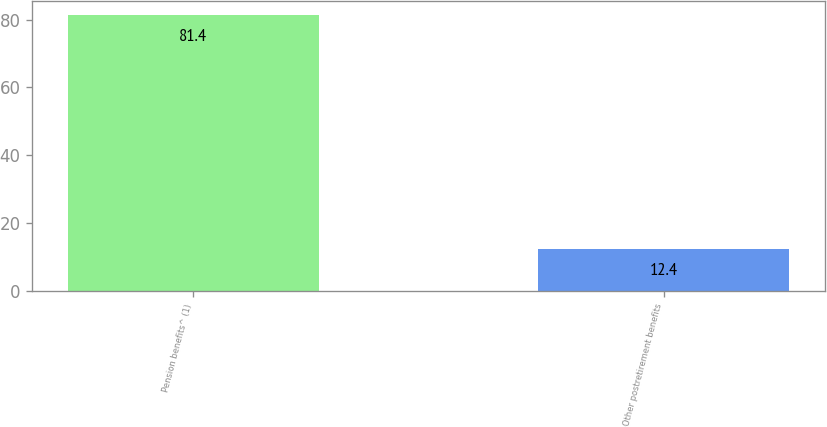Convert chart. <chart><loc_0><loc_0><loc_500><loc_500><bar_chart><fcel>Pension benefits^ (1)<fcel>Other postretirement benefits<nl><fcel>81.4<fcel>12.4<nl></chart> 